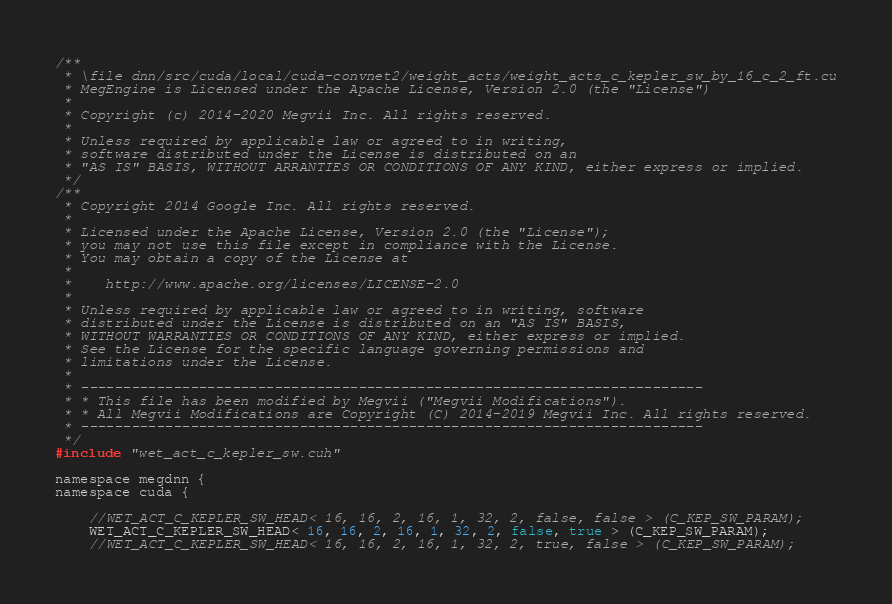<code> <loc_0><loc_0><loc_500><loc_500><_Cuda_>/**
 * \file dnn/src/cuda/local/cuda-convnet2/weight_acts/weight_acts_c_kepler_sw_by_16_c_2_ft.cu
 * MegEngine is Licensed under the Apache License, Version 2.0 (the "License")
 *
 * Copyright (c) 2014-2020 Megvii Inc. All rights reserved.
 *
 * Unless required by applicable law or agreed to in writing,
 * software distributed under the License is distributed on an
 * "AS IS" BASIS, WITHOUT ARRANTIES OR CONDITIONS OF ANY KIND, either express or implied.
 */
/**
 * Copyright 2014 Google Inc. All rights reserved.
 *
 * Licensed under the Apache License, Version 2.0 (the "License");
 * you may not use this file except in compliance with the License.
 * You may obtain a copy of the License at
 *
 *    http://www.apache.org/licenses/LICENSE-2.0
 *
 * Unless required by applicable law or agreed to in writing, software
 * distributed under the License is distributed on an "AS IS" BASIS,
 * WITHOUT WARRANTIES OR CONDITIONS OF ANY KIND, either express or implied.
 * See the License for the specific language governing permissions and
 * limitations under the License.
 *
 * --------------------------------------------------------------------------
 * * This file has been modified by Megvii ("Megvii Modifications").
 * * All Megvii Modifications are Copyright (C) 2014-2019 Megvii Inc. All rights reserved.
 * --------------------------------------------------------------------------
 */
#include "wet_act_c_kepler_sw.cuh"

namespace megdnn {
namespace cuda {

    //WET_ACT_C_KEPLER_SW_HEAD< 16, 16, 2, 16, 1, 32, 2, false, false > (C_KEP_SW_PARAM);
    WET_ACT_C_KEPLER_SW_HEAD< 16, 16, 2, 16, 1, 32, 2, false, true > (C_KEP_SW_PARAM);
    //WET_ACT_C_KEPLER_SW_HEAD< 16, 16, 2, 16, 1, 32, 2, true, false > (C_KEP_SW_PARAM);</code> 